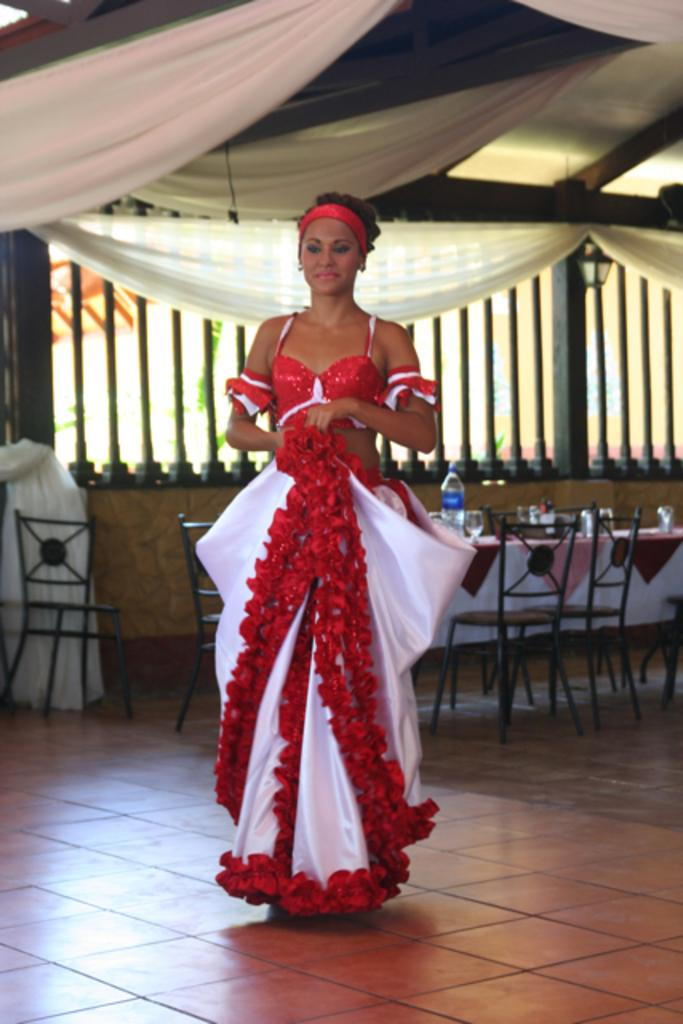Who is the main subject in the image? There is a woman in the image. What is the woman doing in the image? The woman is standing on the floor. What is the woman wearing in the image? The woman is wearing a red and white dress. What type of furniture can be seen in the background of the image? There are chairs and a table in the background of the image. What type of window treatment is present in the image? Curtains are present in the image. What type of riddle is the woman solving in the image? There is no riddle present in the image; the woman is simply standing on the floor. Can you tell me how many forks are visible in the image? There are no forks visible in the image. 